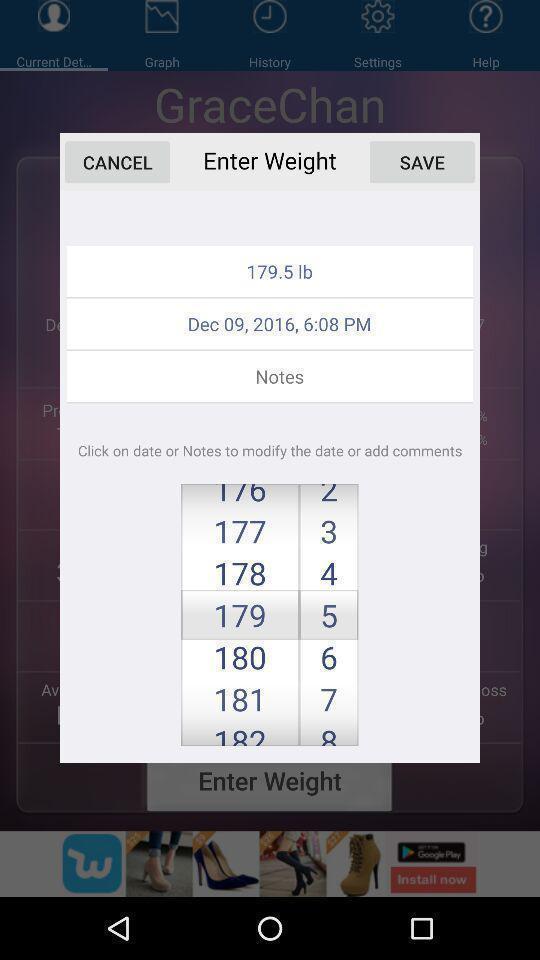Describe the key features of this screenshot. Pop-up shows to enter a weight. 